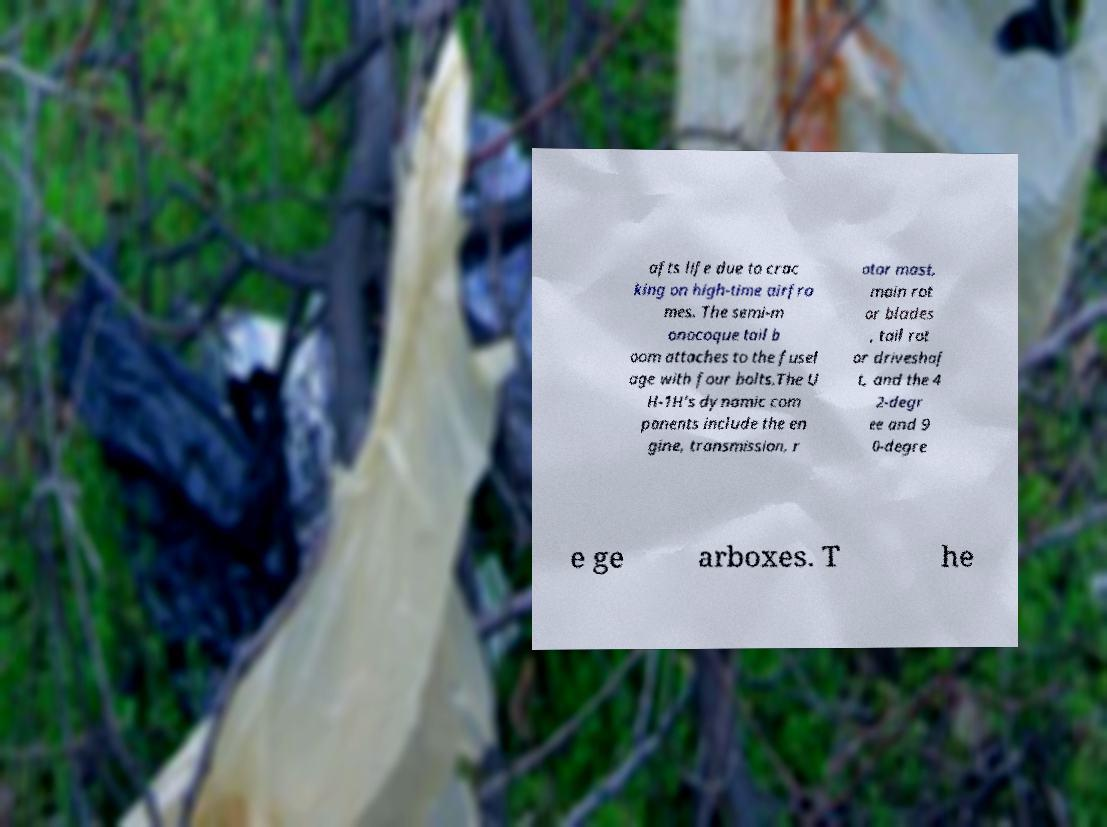Can you read and provide the text displayed in the image?This photo seems to have some interesting text. Can you extract and type it out for me? afts life due to crac king on high-time airfra mes. The semi-m onocoque tail b oom attaches to the fusel age with four bolts.The U H-1H's dynamic com ponents include the en gine, transmission, r otor mast, main rot or blades , tail rot or driveshaf t, and the 4 2-degr ee and 9 0-degre e ge arboxes. T he 